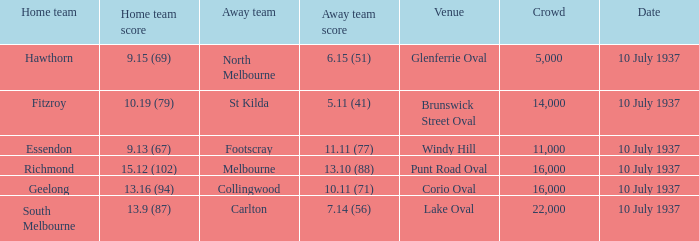What was the least number of spectators when the away team scored 1 16000.0. 